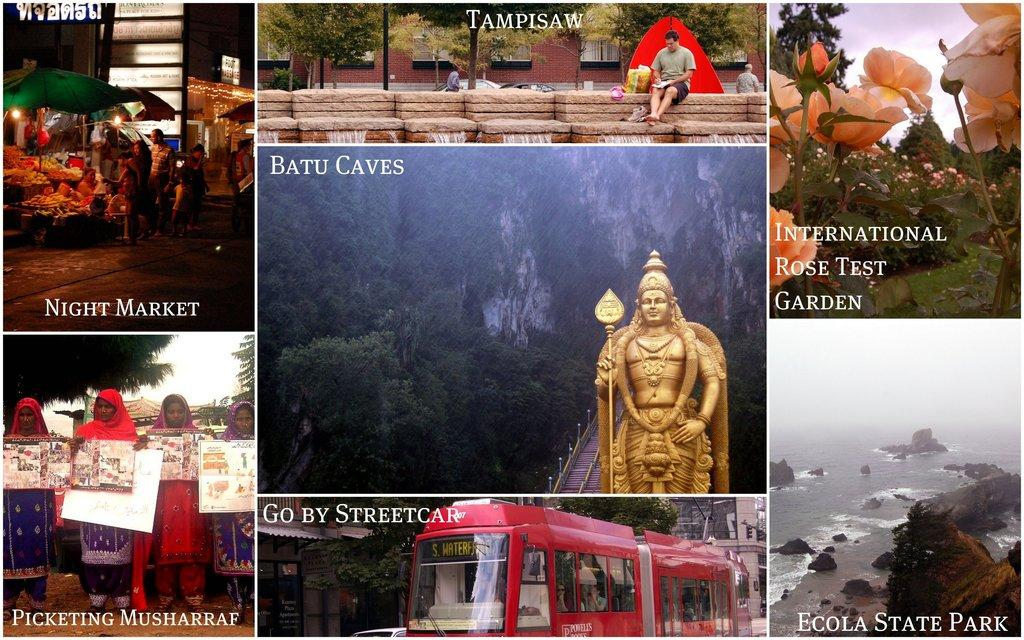<image>
Create a compact narrative representing the image presented. Various pictures of travel destinations and words describing them including one fot the Ecola State Park. 